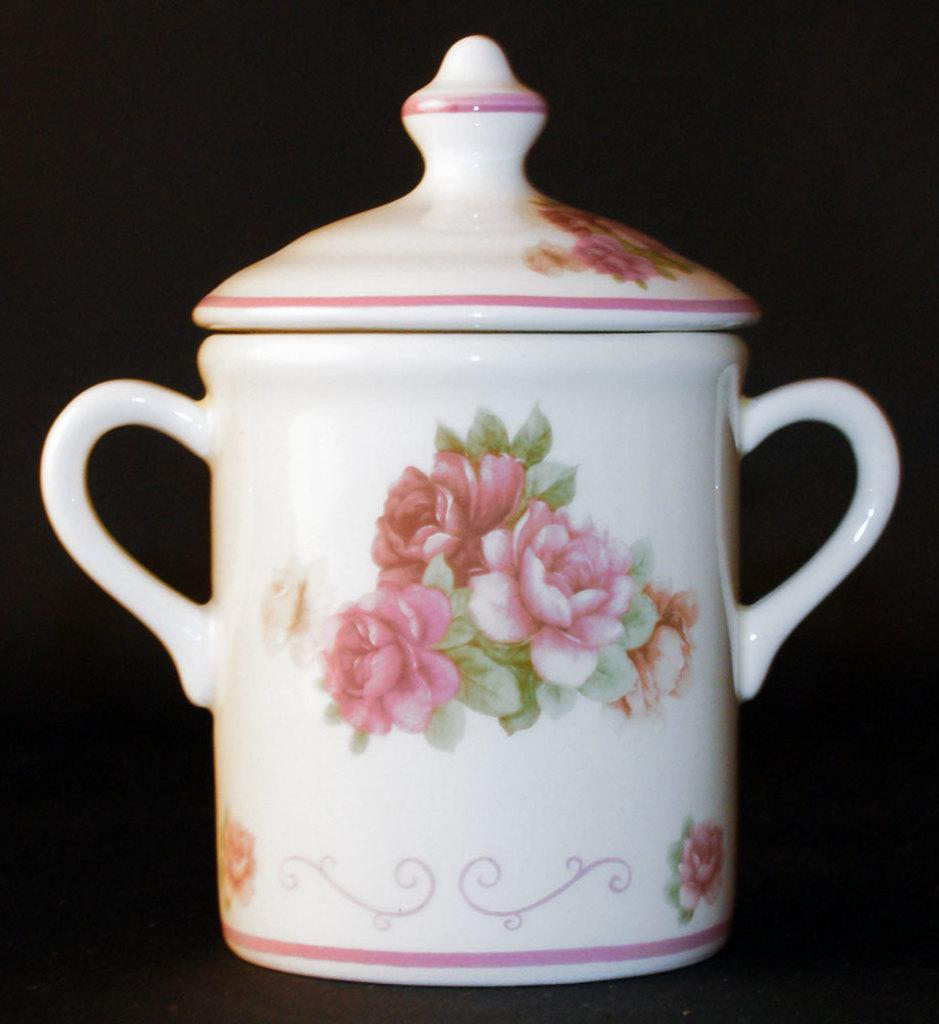What object is the main focus of the image? There is a ceramic pot in the image. What is located on top of the pot? There is a cap in the image. What design can be seen on the pot? The design of flowers is present in the middle of the pot. What is the color of the background in the image? The background of the image is dark. How does the bear interact with the pot in the image? There is no bear present in the image, so it cannot interact with the pot. 